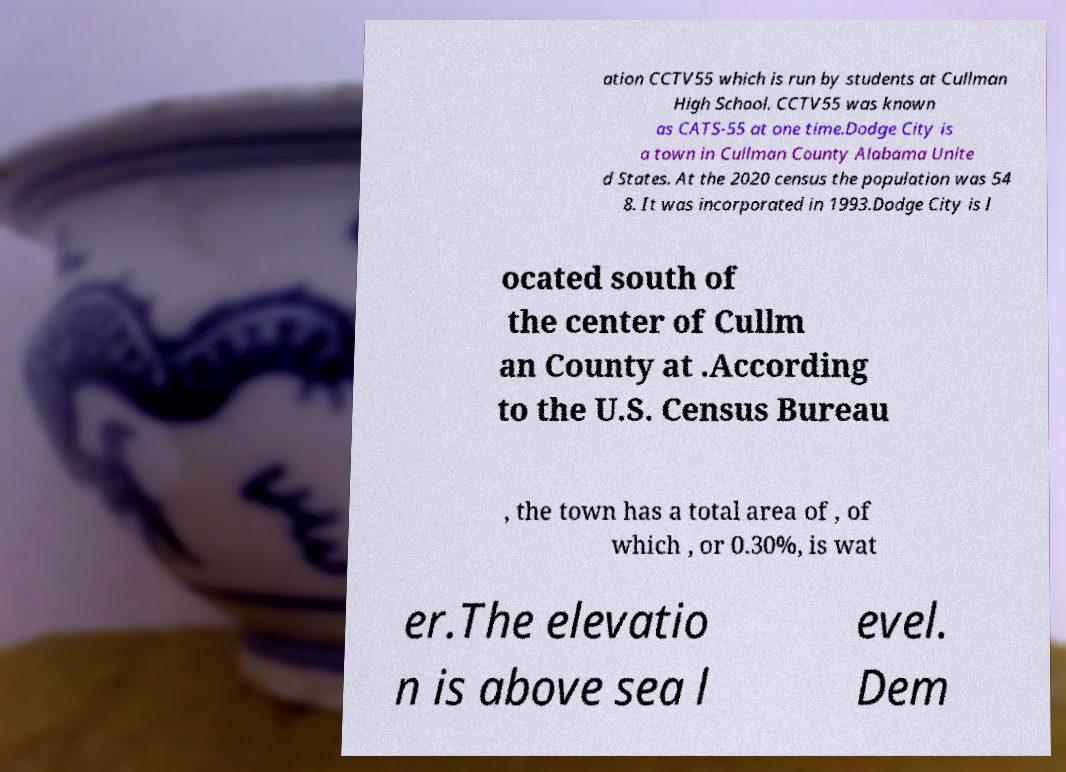There's text embedded in this image that I need extracted. Can you transcribe it verbatim? ation CCTV55 which is run by students at Cullman High School. CCTV55 was known as CATS-55 at one time.Dodge City is a town in Cullman County Alabama Unite d States. At the 2020 census the population was 54 8. It was incorporated in 1993.Dodge City is l ocated south of the center of Cullm an County at .According to the U.S. Census Bureau , the town has a total area of , of which , or 0.30%, is wat er.The elevatio n is above sea l evel. Dem 